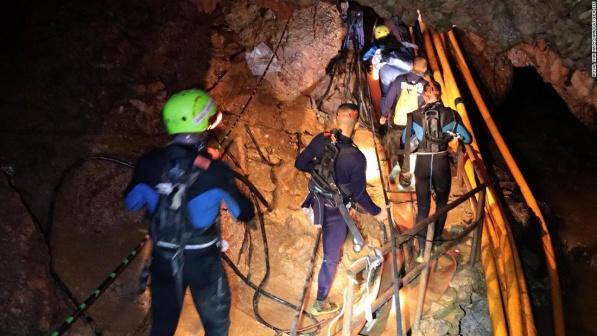In a sci-fi twist, imagine the cave leads to an otherworldly realm. Describe what the adventurers discover at the end of their journey. As the adventurers make their way to the cave's conclusion, they stumble upon a portal shimmering with ethereal light. Stepping through, they find themselves in a vast and surreal landscape where bioluminescent flora illuminates the area with an otherworldly glow. Gigantic, crystal-like structures rise from the ground, refracting the light into mesmerizing patterns. The air is filled with the hum of mysterious energy, and gravity feels slightly altered. Strange creatures, both beautiful and somewhat ominous, roam the terrain. The atmosphere is tinged with mystery, as the adventurers realize they are on the threshold of an unknown dimension, teeming with myriad untold wonders and potential perils. Venturing further into this alien realm, the adventurers encounter floating islands connected by energy bridges. They discover an advanced civilization, long abandoned, with colossal monuments and ruins hinting at a once-thriving society. Through holographic technology left behind, they learn of an ancient race that harnessed the planet's unique energy to achieve remarkable feats. The group must now decide whether to return to their world and share their findings or stay and unlock the secrets of this forgotten civilization, forever altering their destinies. Suddenly, a gigantic, translucent creature emerges, its bioluminescent body pulsating with energy. It communicates through telepathy, revealing it is the guardian of this world and offers to guide the adventurers through the realm's hidden wonders. Together, they travel to an enchanted forest where gravity defies the conventional laws, and to a colossal waterfall that flows upwards, leading to the ancient heart of this enigmatic domain. The guardian reveals that the gateway back to their world lies beyond a series of trials that test their unity, intelligence, and bravery, pushing them to their limits as they strive to return home with unimaginable knowledge and wisdom. 